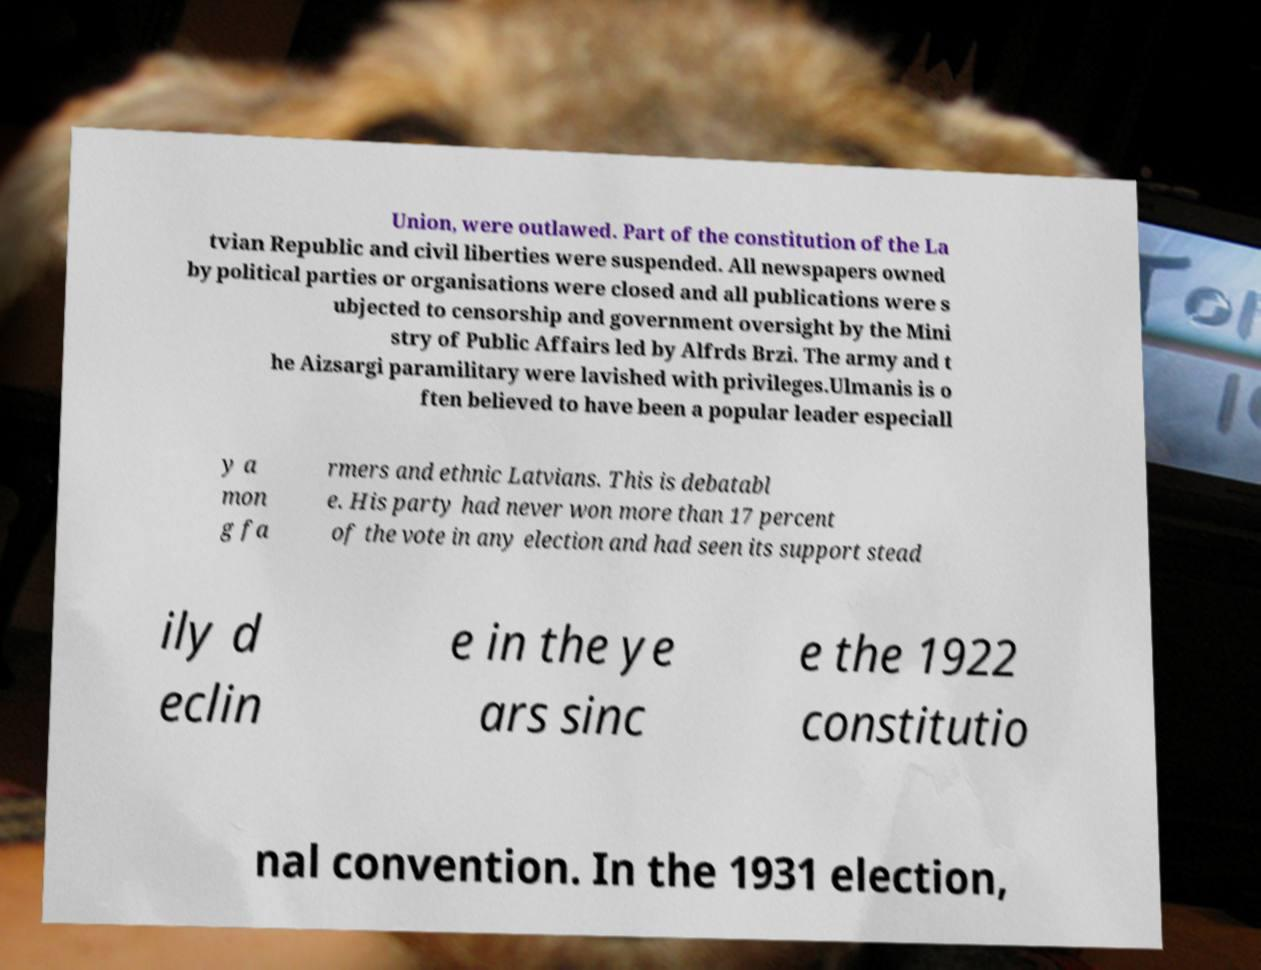Could you extract and type out the text from this image? Union, were outlawed. Part of the constitution of the La tvian Republic and civil liberties were suspended. All newspapers owned by political parties or organisations were closed and all publications were s ubjected to censorship and government oversight by the Mini stry of Public Affairs led by Alfrds Brzi. The army and t he Aizsargi paramilitary were lavished with privileges.Ulmanis is o ften believed to have been a popular leader especiall y a mon g fa rmers and ethnic Latvians. This is debatabl e. His party had never won more than 17 percent of the vote in any election and had seen its support stead ily d eclin e in the ye ars sinc e the 1922 constitutio nal convention. In the 1931 election, 